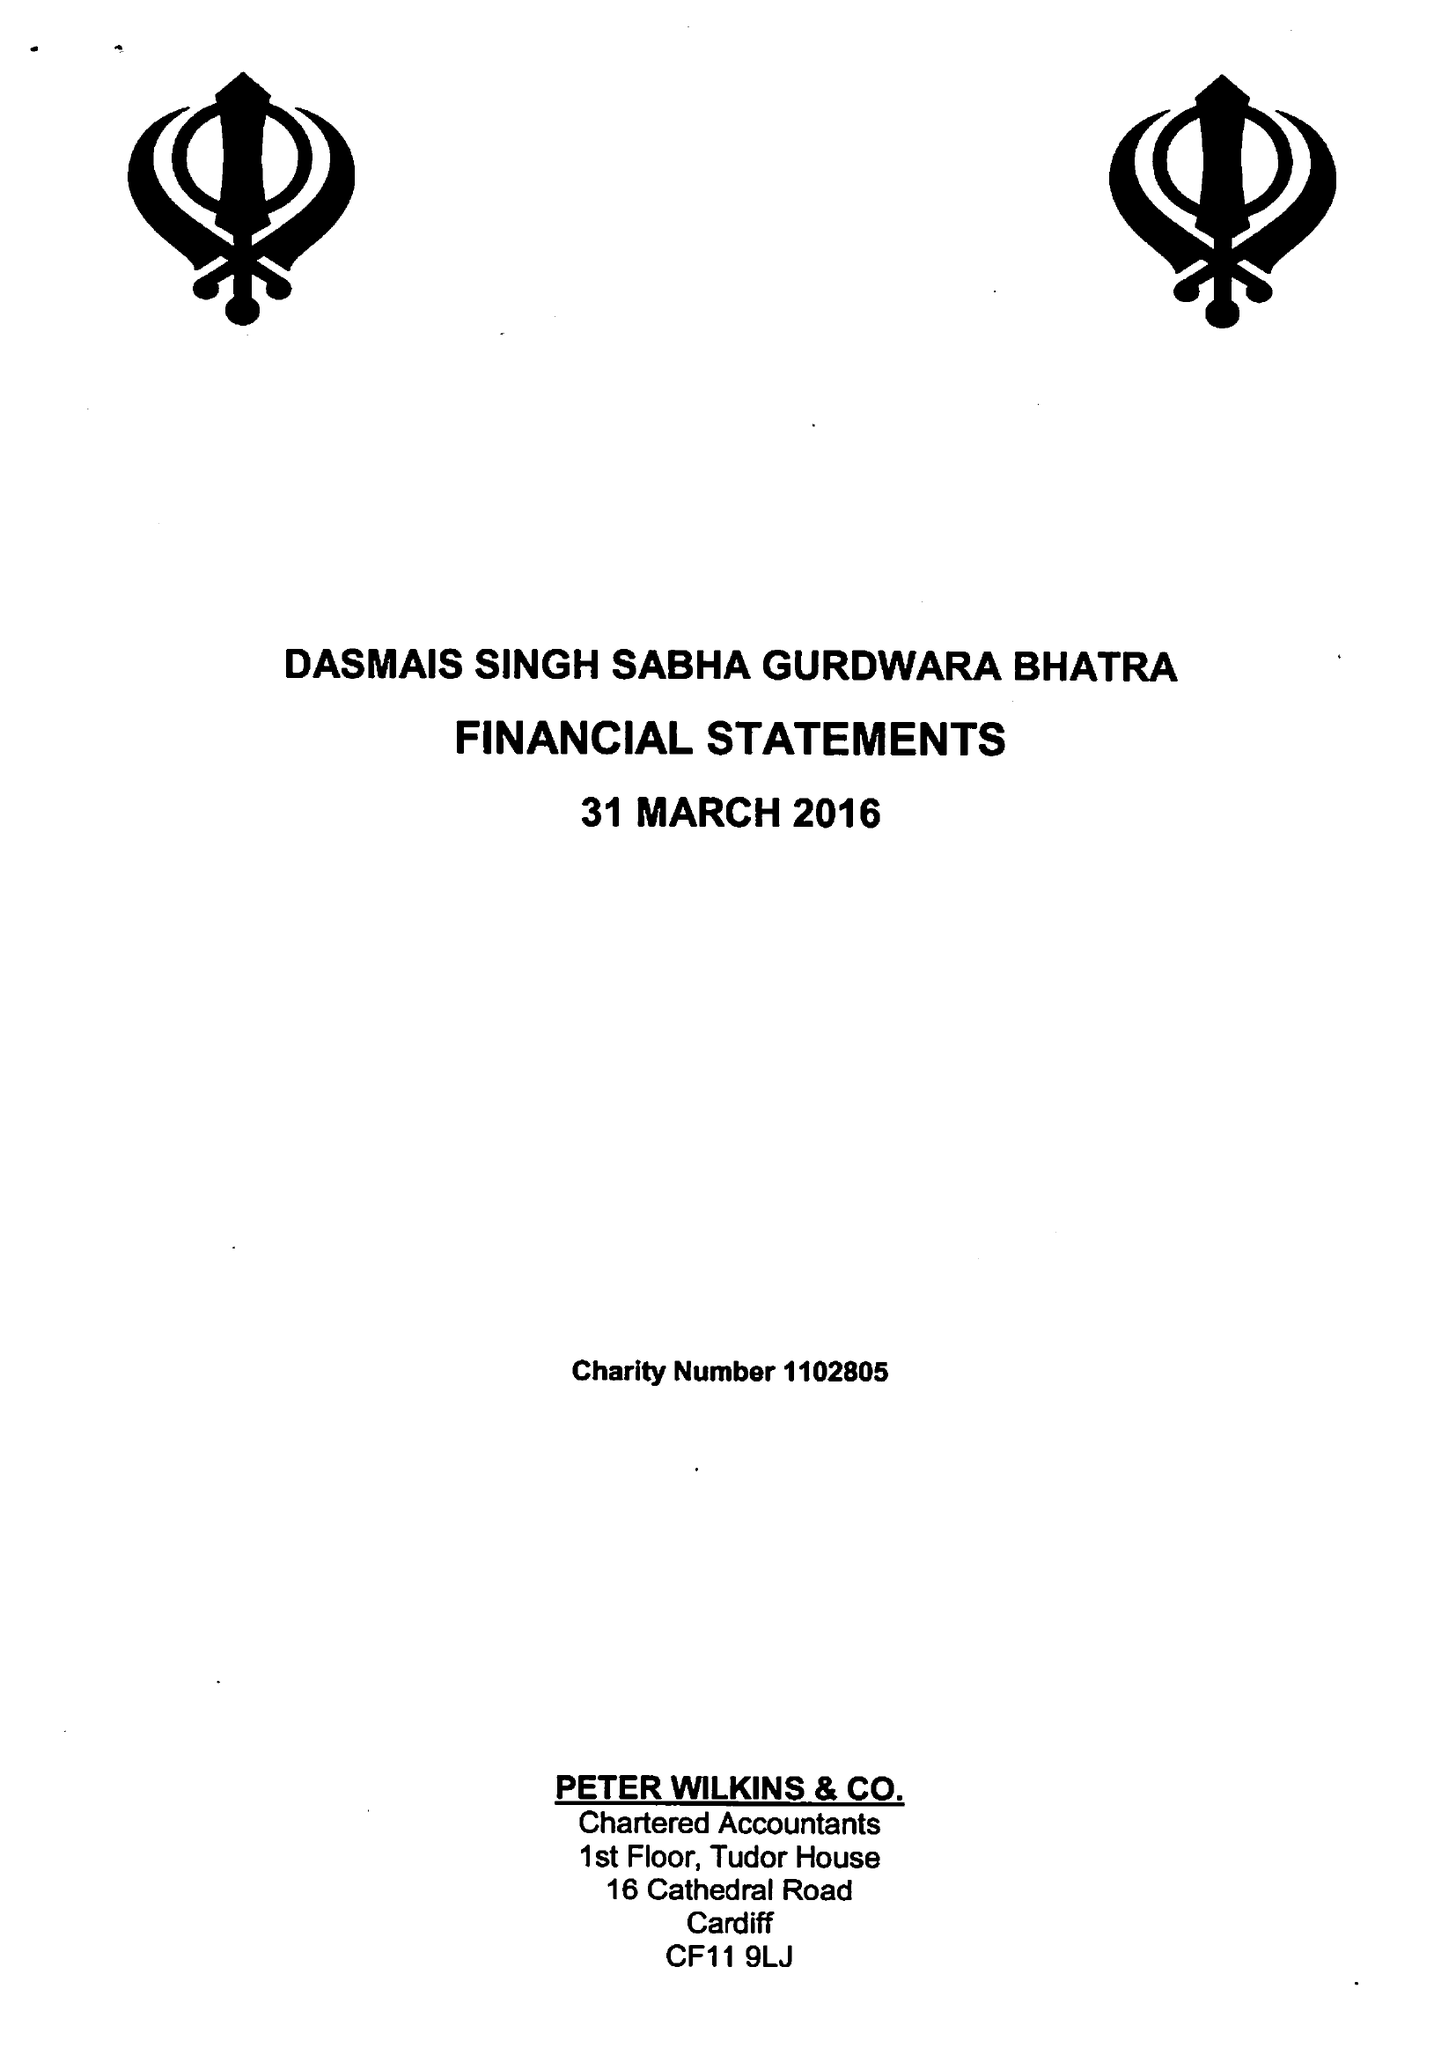What is the value for the charity_name?
Answer the question using a single word or phrase. Dasmais Singh Saba Gurdwara Bhatra 